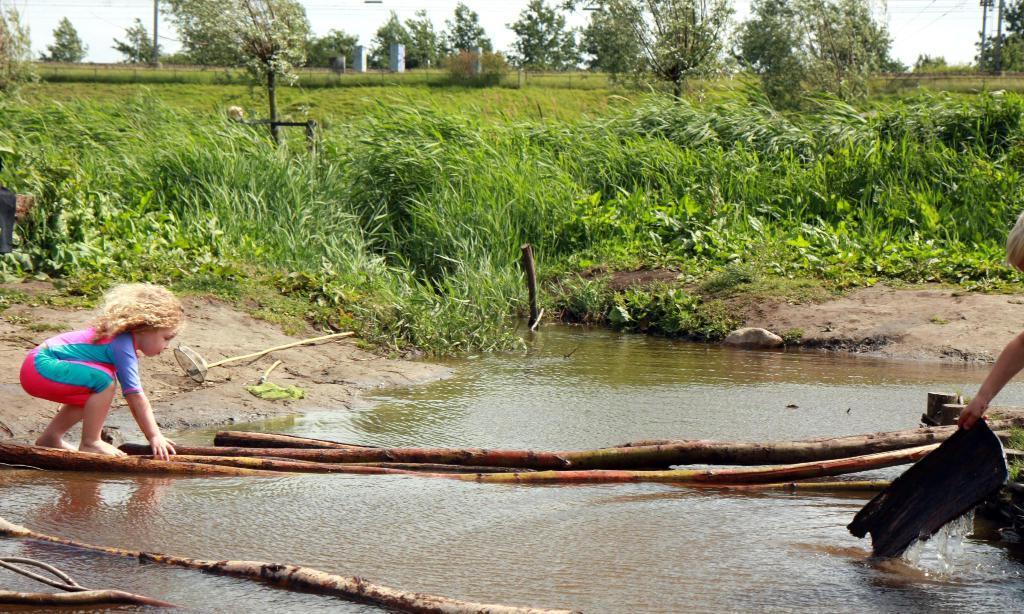Could you give a brief overview of what you see in this image? In this picture we can see a kid on the left side, at the bottom there is water, we can see some plants and trees in the background, there is the sky at the top of the picture, we can see a person's hand on the right side. 